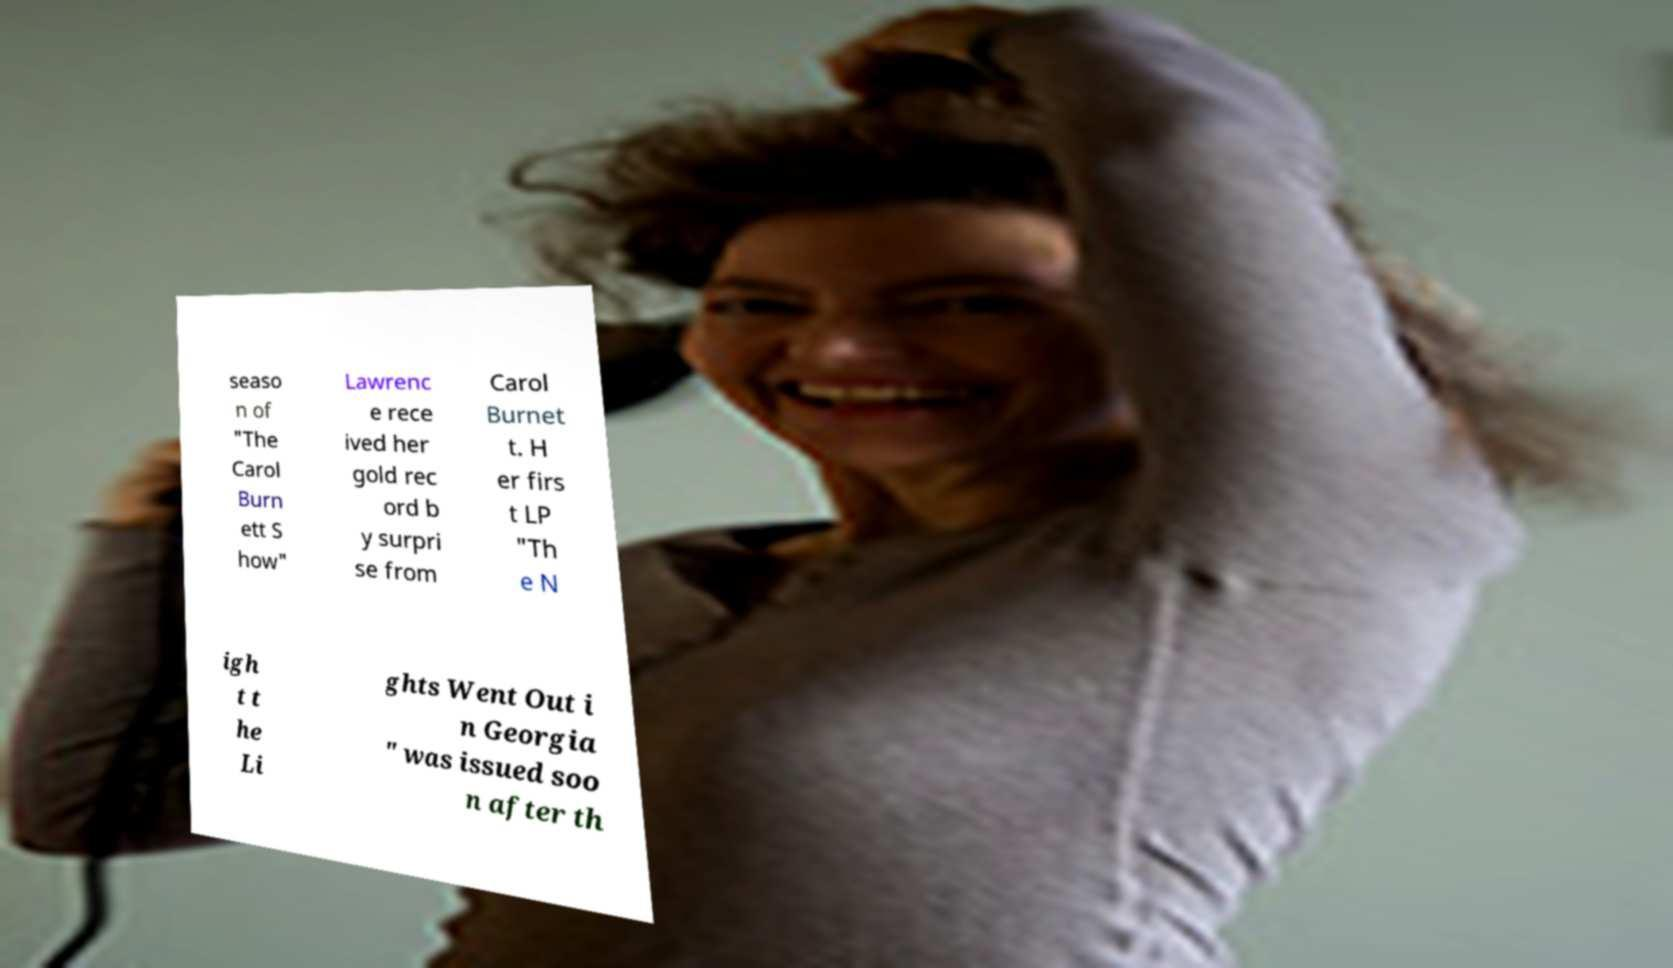What messages or text are displayed in this image? I need them in a readable, typed format. seaso n of "The Carol Burn ett S how" Lawrenc e rece ived her gold rec ord b y surpri se from Carol Burnet t. H er firs t LP "Th e N igh t t he Li ghts Went Out i n Georgia " was issued soo n after th 